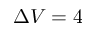<formula> <loc_0><loc_0><loc_500><loc_500>\Delta V = 4</formula> 